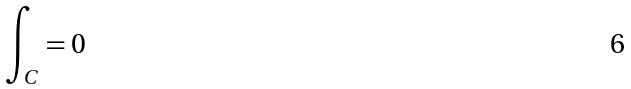<formula> <loc_0><loc_0><loc_500><loc_500>\int _ { C } = 0</formula> 